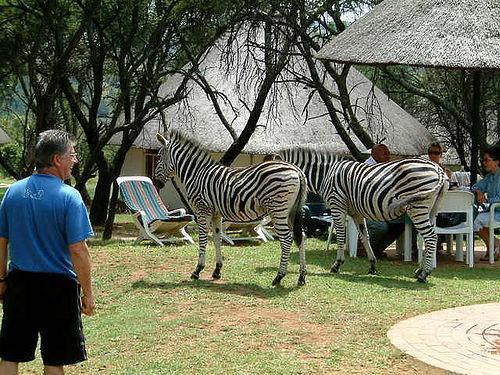How many zebras can be seen?
Give a very brief answer. 2. How many people are on the boat not at the dock?
Give a very brief answer. 0. 